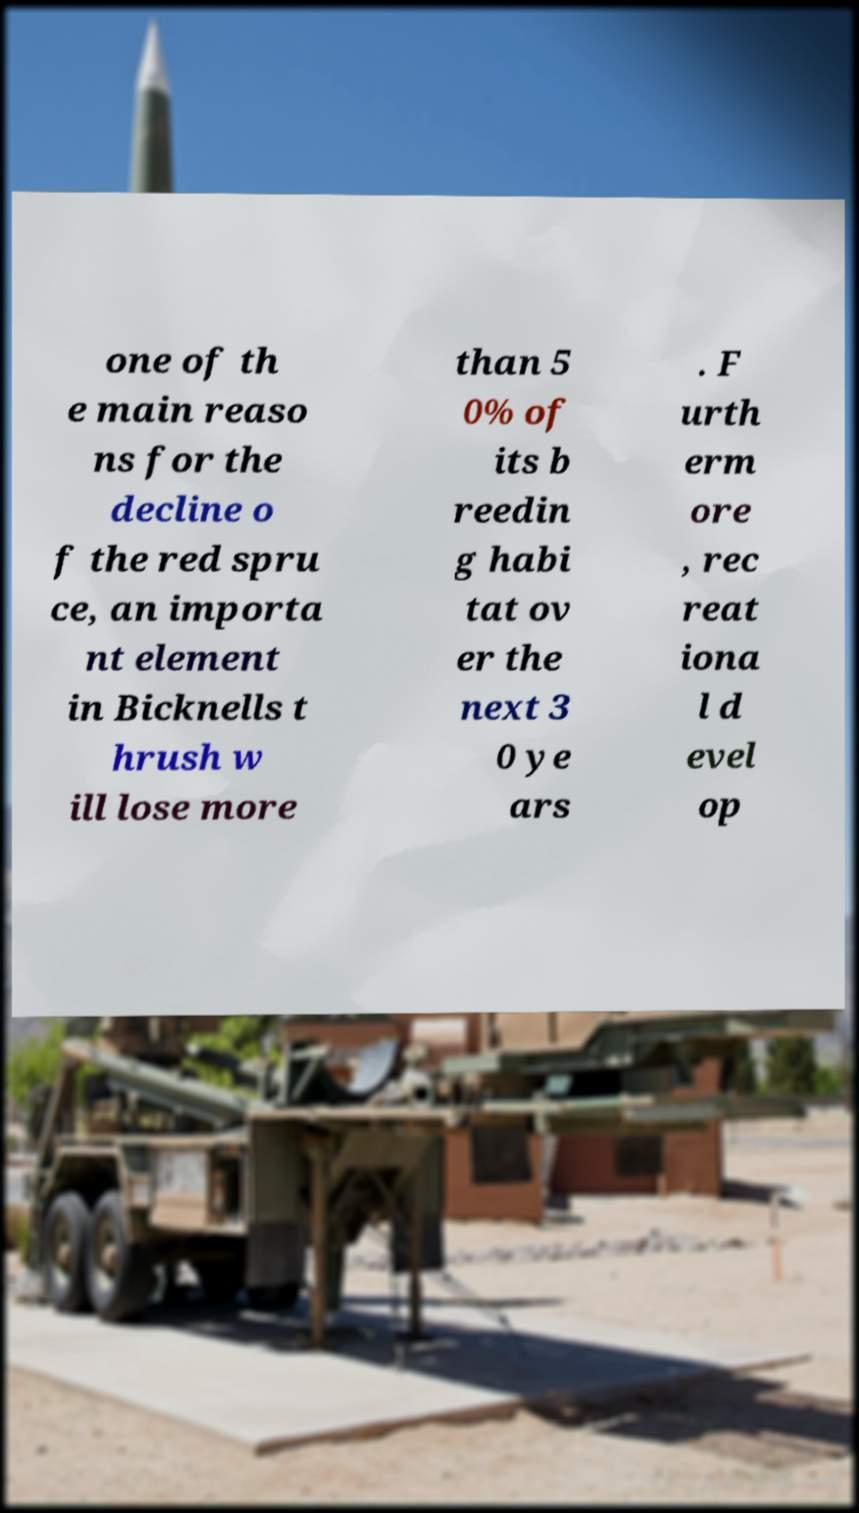I need the written content from this picture converted into text. Can you do that? one of th e main reaso ns for the decline o f the red spru ce, an importa nt element in Bicknells t hrush w ill lose more than 5 0% of its b reedin g habi tat ov er the next 3 0 ye ars . F urth erm ore , rec reat iona l d evel op 